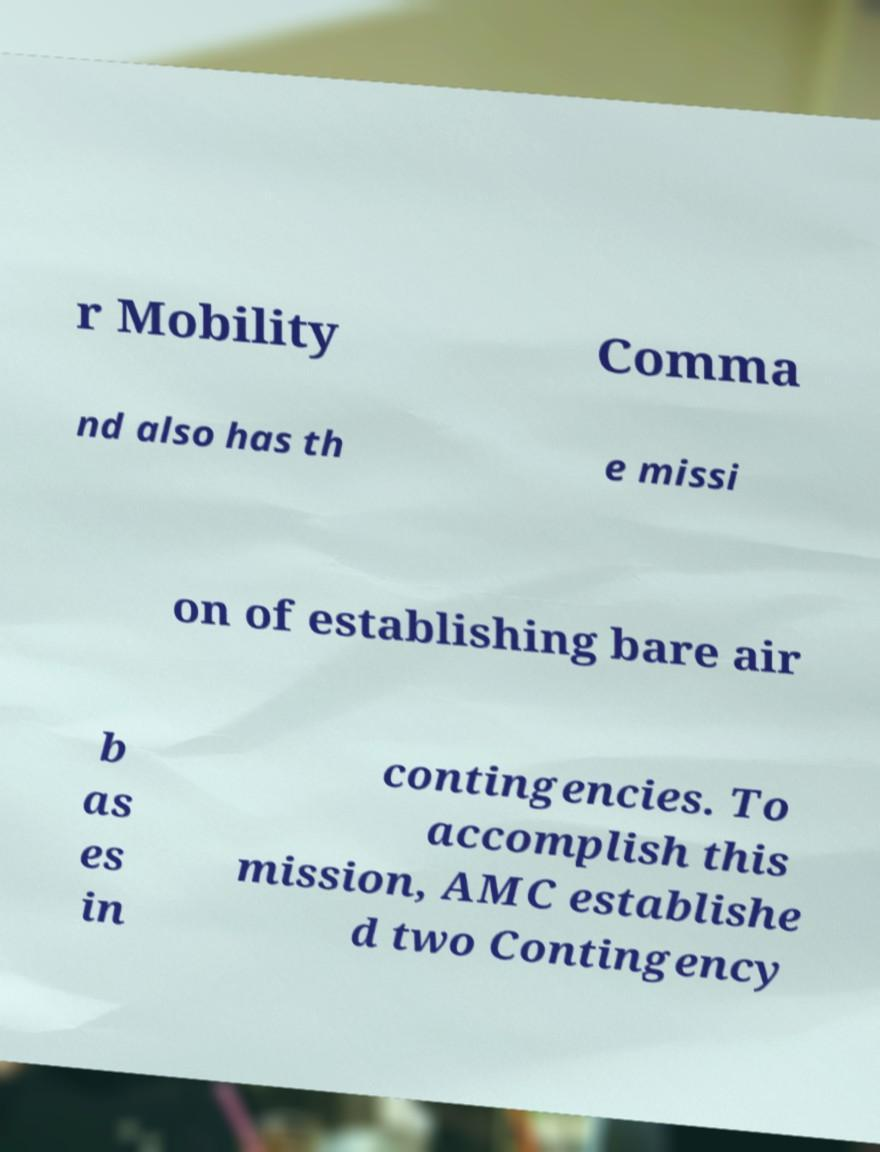Can you read and provide the text displayed in the image?This photo seems to have some interesting text. Can you extract and type it out for me? r Mobility Comma nd also has th e missi on of establishing bare air b as es in contingencies. To accomplish this mission, AMC establishe d two Contingency 